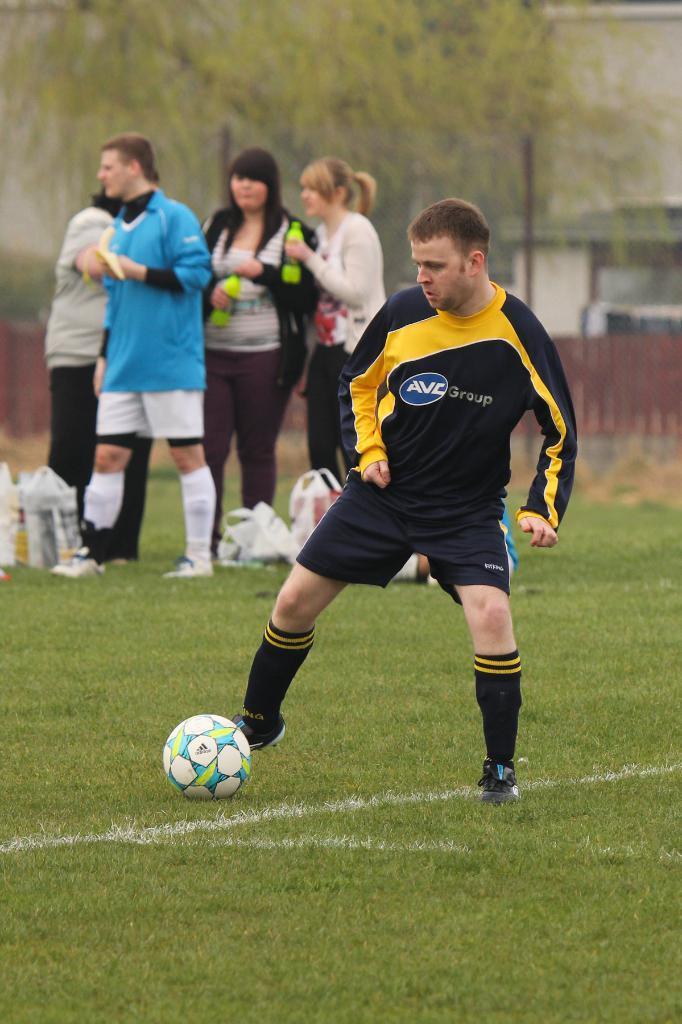In one or two sentences, can you explain what this image depicts? Here in the middle we can see a Man kicking a football and behind him we can see group of people standing with bottles in their hand there are trees present 